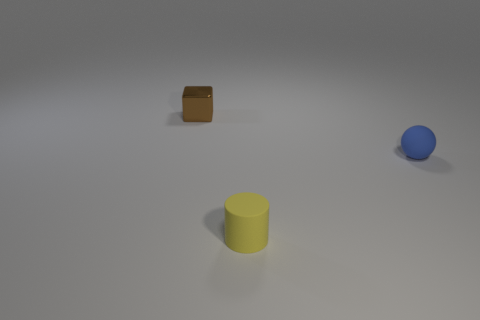Add 2 large rubber spheres. How many objects exist? 5 Subtract all balls. How many objects are left? 2 Subtract 1 blocks. How many blocks are left? 0 Subtract all brown spheres. Subtract all brown cylinders. How many spheres are left? 1 Subtract all tiny blue balls. Subtract all blue balls. How many objects are left? 1 Add 1 yellow cylinders. How many yellow cylinders are left? 2 Add 3 tiny gray metal things. How many tiny gray metal things exist? 3 Subtract 0 green cubes. How many objects are left? 3 